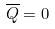Convert formula to latex. <formula><loc_0><loc_0><loc_500><loc_500>\overline { Q } = 0</formula> 